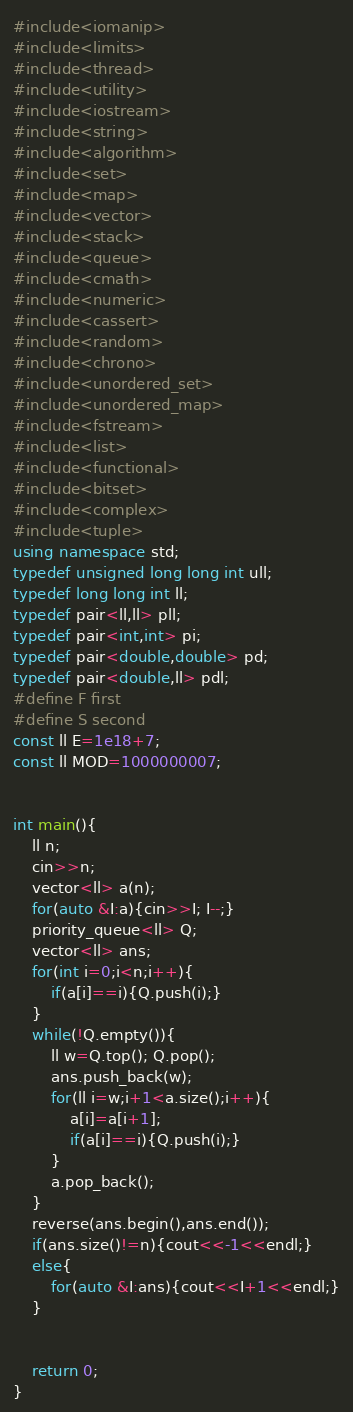Convert code to text. <code><loc_0><loc_0><loc_500><loc_500><_C++_>#include<iomanip>
#include<limits>
#include<thread>
#include<utility>
#include<iostream>
#include<string>
#include<algorithm>
#include<set>
#include<map>
#include<vector>
#include<stack>
#include<queue>
#include<cmath>
#include<numeric>
#include<cassert>
#include<random>
#include<chrono>
#include<unordered_set>
#include<unordered_map>
#include<fstream>
#include<list>
#include<functional>
#include<bitset>
#include<complex>
#include<tuple>
using namespace std;
typedef unsigned long long int ull;
typedef long long int ll;
typedef pair<ll,ll> pll;
typedef pair<int,int> pi;
typedef pair<double,double> pd;
typedef pair<double,ll> pdl;
#define F first
#define S second
const ll E=1e18+7;
const ll MOD=1000000007;


int main(){
    ll n;
    cin>>n;
    vector<ll> a(n);
    for(auto &I:a){cin>>I; I--;}
    priority_queue<ll> Q;
    vector<ll> ans;
    for(int i=0;i<n;i++){
        if(a[i]==i){Q.push(i);}
    }
    while(!Q.empty()){
        ll w=Q.top(); Q.pop();
        ans.push_back(w);
        for(ll i=w;i+1<a.size();i++){
            a[i]=a[i+1];
            if(a[i]==i){Q.push(i);}
        }
        a.pop_back();
    }
    reverse(ans.begin(),ans.end());
    if(ans.size()!=n){cout<<-1<<endl;}
    else{
        for(auto &I:ans){cout<<I+1<<endl;}
    }
    
    
    return 0;
}
</code> 